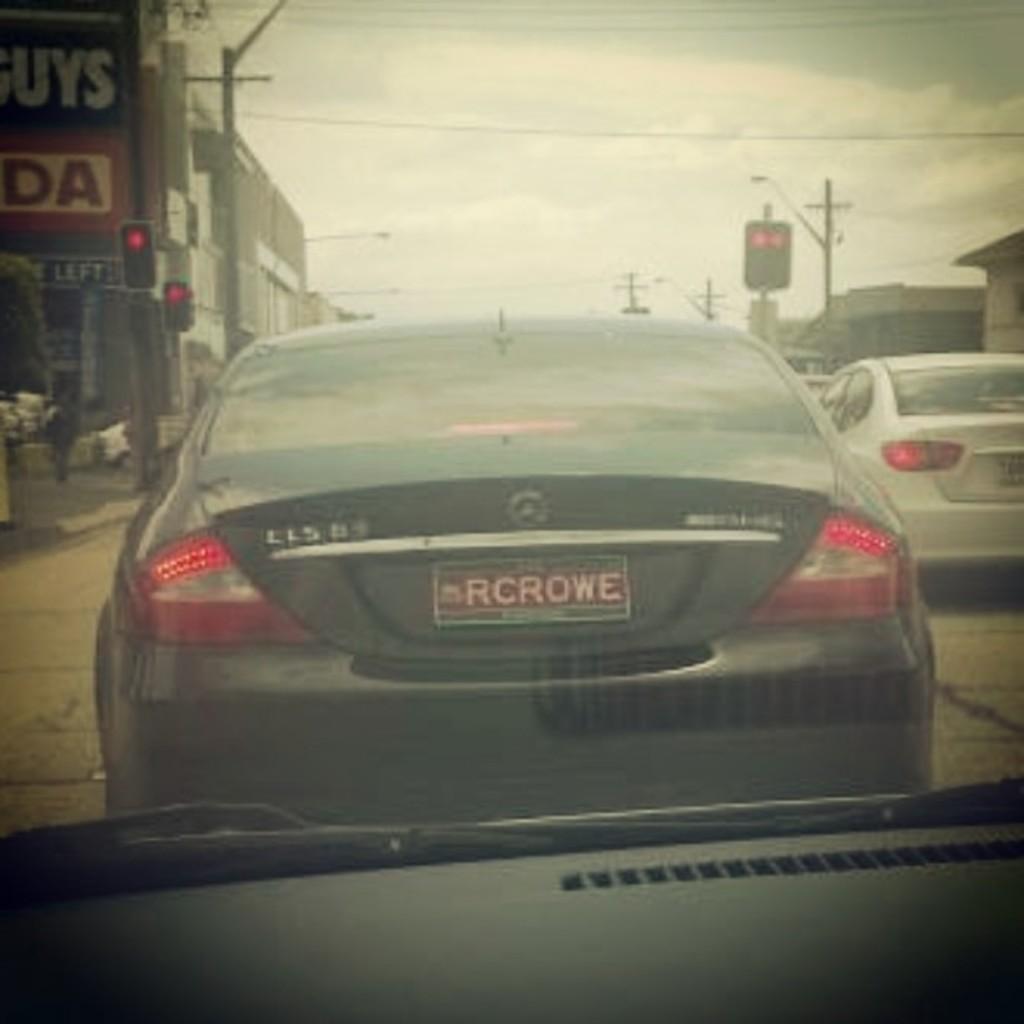In one or two sentences, can you explain what this image depicts? This image is taken in a car. In the middle of the image there is a windshield and through the windshield we can see there are a few cars parked on the road. There are a few poles with street lights and there are a few signal lights. At the top of the image there is the sky with clouds and there are a few wires. There are a few buildings and there is a board with a text on it. 